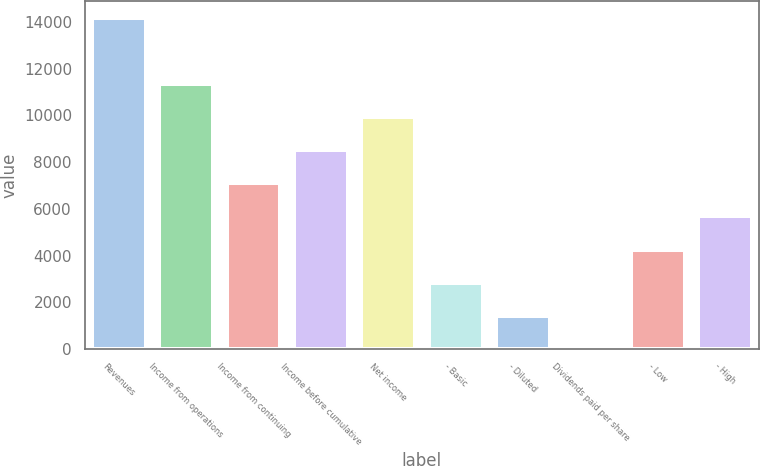<chart> <loc_0><loc_0><loc_500><loc_500><bar_chart><fcel>Revenues<fcel>Income from operations<fcel>Income from continuing<fcel>Income before cumulative<fcel>Net income<fcel>- Basic<fcel>- Diluted<fcel>Dividends paid per share<fcel>- Low<fcel>- High<nl><fcel>14183<fcel>11346.4<fcel>7091.63<fcel>8509.9<fcel>9928.17<fcel>2836.82<fcel>1418.55<fcel>0.28<fcel>4255.09<fcel>5673.36<nl></chart> 